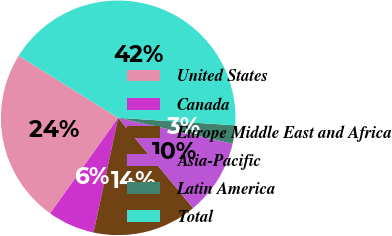Convert chart to OTSL. <chart><loc_0><loc_0><loc_500><loc_500><pie_chart><fcel>United States<fcel>Canada<fcel>Europe Middle East and Africa<fcel>Asia-Pacific<fcel>Latin America<fcel>Total<nl><fcel>24.04%<fcel>6.47%<fcel>14.4%<fcel>10.44%<fcel>2.51%<fcel>42.14%<nl></chart> 